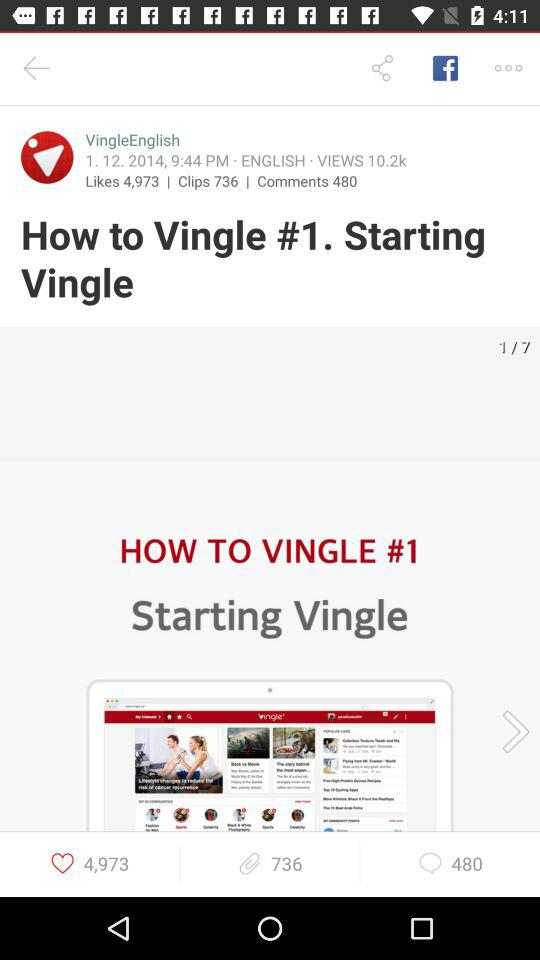What's the total number of likes? The total number of likes is 4,973. 